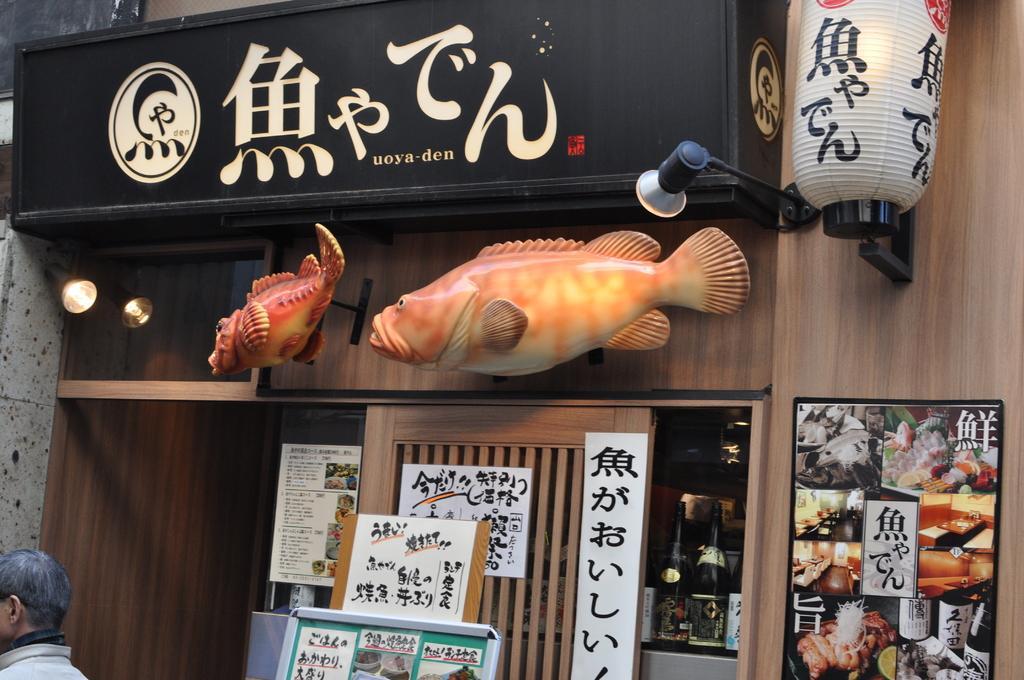Please provide a concise description of this image. In this picture I can see a person in the bottom left hand corner. I can see led board at the top. I can see lights on the right side. I can see toy fishes. I can see a board at the bottom. 